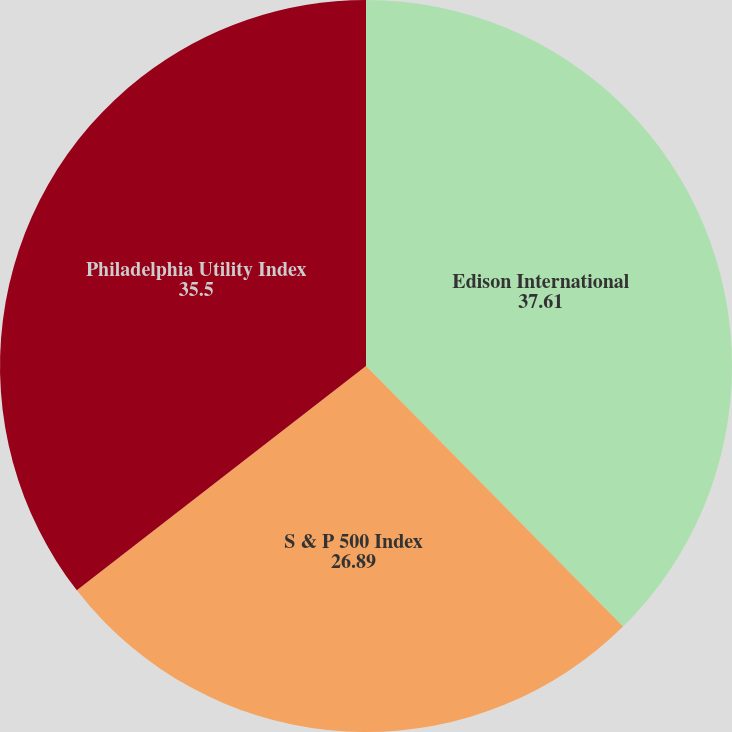Convert chart. <chart><loc_0><loc_0><loc_500><loc_500><pie_chart><fcel>Edison International<fcel>S & P 500 Index<fcel>Philadelphia Utility Index<nl><fcel>37.61%<fcel>26.89%<fcel>35.5%<nl></chart> 